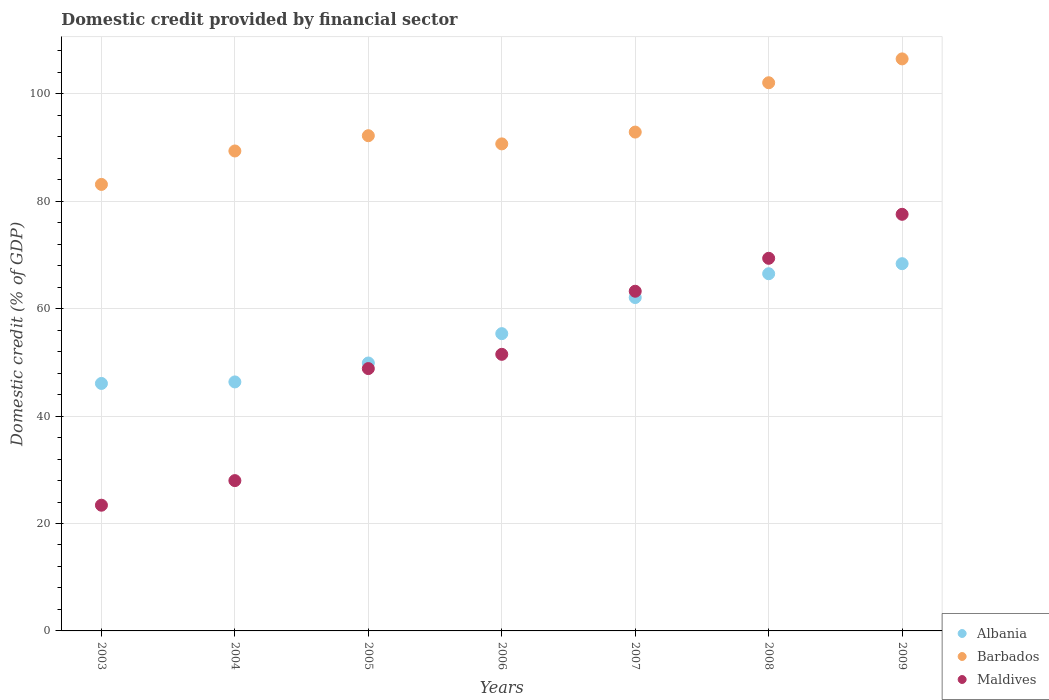How many different coloured dotlines are there?
Keep it short and to the point. 3. What is the domestic credit in Barbados in 2007?
Provide a succinct answer. 92.89. Across all years, what is the maximum domestic credit in Maldives?
Offer a terse response. 77.58. Across all years, what is the minimum domestic credit in Barbados?
Give a very brief answer. 83.14. In which year was the domestic credit in Albania maximum?
Your response must be concise. 2009. What is the total domestic credit in Maldives in the graph?
Your answer should be very brief. 361.96. What is the difference between the domestic credit in Maldives in 2004 and that in 2008?
Your response must be concise. -41.39. What is the difference between the domestic credit in Barbados in 2008 and the domestic credit in Albania in 2007?
Your response must be concise. 40. What is the average domestic credit in Maldives per year?
Provide a succinct answer. 51.71. In the year 2004, what is the difference between the domestic credit in Barbados and domestic credit in Albania?
Your answer should be very brief. 43. What is the ratio of the domestic credit in Maldives in 2005 to that in 2008?
Your response must be concise. 0.7. Is the difference between the domestic credit in Barbados in 2004 and 2006 greater than the difference between the domestic credit in Albania in 2004 and 2006?
Your answer should be compact. Yes. What is the difference between the highest and the second highest domestic credit in Barbados?
Your answer should be compact. 4.44. What is the difference between the highest and the lowest domestic credit in Albania?
Ensure brevity in your answer.  22.3. Is it the case that in every year, the sum of the domestic credit in Barbados and domestic credit in Albania  is greater than the domestic credit in Maldives?
Your answer should be very brief. Yes. Does the domestic credit in Maldives monotonically increase over the years?
Offer a terse response. Yes. Does the graph contain any zero values?
Provide a short and direct response. No. Does the graph contain grids?
Offer a very short reply. Yes. What is the title of the graph?
Offer a very short reply. Domestic credit provided by financial sector. What is the label or title of the Y-axis?
Offer a very short reply. Domestic credit (% of GDP). What is the Domestic credit (% of GDP) in Albania in 2003?
Offer a terse response. 46.08. What is the Domestic credit (% of GDP) of Barbados in 2003?
Offer a very short reply. 83.14. What is the Domestic credit (% of GDP) of Maldives in 2003?
Ensure brevity in your answer.  23.41. What is the Domestic credit (% of GDP) of Albania in 2004?
Your answer should be compact. 46.36. What is the Domestic credit (% of GDP) in Barbados in 2004?
Your answer should be compact. 89.37. What is the Domestic credit (% of GDP) of Maldives in 2004?
Keep it short and to the point. 27.99. What is the Domestic credit (% of GDP) in Albania in 2005?
Keep it short and to the point. 49.89. What is the Domestic credit (% of GDP) in Barbados in 2005?
Offer a very short reply. 92.21. What is the Domestic credit (% of GDP) in Maldives in 2005?
Your response must be concise. 48.85. What is the Domestic credit (% of GDP) of Albania in 2006?
Offer a terse response. 55.35. What is the Domestic credit (% of GDP) in Barbados in 2006?
Your response must be concise. 90.69. What is the Domestic credit (% of GDP) in Maldives in 2006?
Offer a very short reply. 51.5. What is the Domestic credit (% of GDP) of Albania in 2007?
Offer a terse response. 62.08. What is the Domestic credit (% of GDP) of Barbados in 2007?
Your answer should be compact. 92.89. What is the Domestic credit (% of GDP) of Maldives in 2007?
Give a very brief answer. 63.25. What is the Domestic credit (% of GDP) of Albania in 2008?
Ensure brevity in your answer.  66.51. What is the Domestic credit (% of GDP) of Barbados in 2008?
Your answer should be compact. 102.07. What is the Domestic credit (% of GDP) in Maldives in 2008?
Your answer should be very brief. 69.38. What is the Domestic credit (% of GDP) of Albania in 2009?
Give a very brief answer. 68.38. What is the Domestic credit (% of GDP) of Barbados in 2009?
Ensure brevity in your answer.  106.52. What is the Domestic credit (% of GDP) in Maldives in 2009?
Make the answer very short. 77.58. Across all years, what is the maximum Domestic credit (% of GDP) of Albania?
Provide a short and direct response. 68.38. Across all years, what is the maximum Domestic credit (% of GDP) of Barbados?
Your answer should be compact. 106.52. Across all years, what is the maximum Domestic credit (% of GDP) of Maldives?
Give a very brief answer. 77.58. Across all years, what is the minimum Domestic credit (% of GDP) of Albania?
Your answer should be very brief. 46.08. Across all years, what is the minimum Domestic credit (% of GDP) of Barbados?
Offer a very short reply. 83.14. Across all years, what is the minimum Domestic credit (% of GDP) of Maldives?
Provide a succinct answer. 23.41. What is the total Domestic credit (% of GDP) of Albania in the graph?
Give a very brief answer. 394.66. What is the total Domestic credit (% of GDP) of Barbados in the graph?
Give a very brief answer. 656.89. What is the total Domestic credit (% of GDP) of Maldives in the graph?
Offer a very short reply. 361.96. What is the difference between the Domestic credit (% of GDP) of Albania in 2003 and that in 2004?
Your answer should be compact. -0.28. What is the difference between the Domestic credit (% of GDP) in Barbados in 2003 and that in 2004?
Offer a terse response. -6.23. What is the difference between the Domestic credit (% of GDP) of Maldives in 2003 and that in 2004?
Provide a succinct answer. -4.58. What is the difference between the Domestic credit (% of GDP) of Albania in 2003 and that in 2005?
Your answer should be compact. -3.81. What is the difference between the Domestic credit (% of GDP) in Barbados in 2003 and that in 2005?
Offer a terse response. -9.07. What is the difference between the Domestic credit (% of GDP) in Maldives in 2003 and that in 2005?
Make the answer very short. -25.44. What is the difference between the Domestic credit (% of GDP) of Albania in 2003 and that in 2006?
Keep it short and to the point. -9.27. What is the difference between the Domestic credit (% of GDP) of Barbados in 2003 and that in 2006?
Keep it short and to the point. -7.55. What is the difference between the Domestic credit (% of GDP) of Maldives in 2003 and that in 2006?
Make the answer very short. -28.1. What is the difference between the Domestic credit (% of GDP) in Albania in 2003 and that in 2007?
Your answer should be very brief. -16. What is the difference between the Domestic credit (% of GDP) of Barbados in 2003 and that in 2007?
Ensure brevity in your answer.  -9.75. What is the difference between the Domestic credit (% of GDP) in Maldives in 2003 and that in 2007?
Give a very brief answer. -39.84. What is the difference between the Domestic credit (% of GDP) in Albania in 2003 and that in 2008?
Your answer should be very brief. -20.43. What is the difference between the Domestic credit (% of GDP) of Barbados in 2003 and that in 2008?
Your answer should be compact. -18.93. What is the difference between the Domestic credit (% of GDP) of Maldives in 2003 and that in 2008?
Keep it short and to the point. -45.98. What is the difference between the Domestic credit (% of GDP) of Albania in 2003 and that in 2009?
Provide a succinct answer. -22.3. What is the difference between the Domestic credit (% of GDP) in Barbados in 2003 and that in 2009?
Ensure brevity in your answer.  -23.37. What is the difference between the Domestic credit (% of GDP) of Maldives in 2003 and that in 2009?
Give a very brief answer. -54.17. What is the difference between the Domestic credit (% of GDP) of Albania in 2004 and that in 2005?
Provide a succinct answer. -3.52. What is the difference between the Domestic credit (% of GDP) of Barbados in 2004 and that in 2005?
Provide a short and direct response. -2.84. What is the difference between the Domestic credit (% of GDP) of Maldives in 2004 and that in 2005?
Your response must be concise. -20.86. What is the difference between the Domestic credit (% of GDP) of Albania in 2004 and that in 2006?
Make the answer very short. -8.99. What is the difference between the Domestic credit (% of GDP) of Barbados in 2004 and that in 2006?
Make the answer very short. -1.32. What is the difference between the Domestic credit (% of GDP) in Maldives in 2004 and that in 2006?
Your response must be concise. -23.52. What is the difference between the Domestic credit (% of GDP) of Albania in 2004 and that in 2007?
Make the answer very short. -15.71. What is the difference between the Domestic credit (% of GDP) of Barbados in 2004 and that in 2007?
Offer a very short reply. -3.52. What is the difference between the Domestic credit (% of GDP) of Maldives in 2004 and that in 2007?
Your answer should be compact. -35.26. What is the difference between the Domestic credit (% of GDP) of Albania in 2004 and that in 2008?
Offer a terse response. -20.15. What is the difference between the Domestic credit (% of GDP) of Barbados in 2004 and that in 2008?
Provide a short and direct response. -12.7. What is the difference between the Domestic credit (% of GDP) of Maldives in 2004 and that in 2008?
Your answer should be very brief. -41.4. What is the difference between the Domestic credit (% of GDP) of Albania in 2004 and that in 2009?
Ensure brevity in your answer.  -22.02. What is the difference between the Domestic credit (% of GDP) of Barbados in 2004 and that in 2009?
Your response must be concise. -17.15. What is the difference between the Domestic credit (% of GDP) of Maldives in 2004 and that in 2009?
Your answer should be very brief. -49.59. What is the difference between the Domestic credit (% of GDP) of Albania in 2005 and that in 2006?
Keep it short and to the point. -5.47. What is the difference between the Domestic credit (% of GDP) in Barbados in 2005 and that in 2006?
Ensure brevity in your answer.  1.52. What is the difference between the Domestic credit (% of GDP) in Maldives in 2005 and that in 2006?
Your answer should be very brief. -2.66. What is the difference between the Domestic credit (% of GDP) of Albania in 2005 and that in 2007?
Offer a very short reply. -12.19. What is the difference between the Domestic credit (% of GDP) of Barbados in 2005 and that in 2007?
Your answer should be very brief. -0.68. What is the difference between the Domestic credit (% of GDP) in Maldives in 2005 and that in 2007?
Provide a succinct answer. -14.4. What is the difference between the Domestic credit (% of GDP) of Albania in 2005 and that in 2008?
Your response must be concise. -16.62. What is the difference between the Domestic credit (% of GDP) in Barbados in 2005 and that in 2008?
Provide a succinct answer. -9.86. What is the difference between the Domestic credit (% of GDP) in Maldives in 2005 and that in 2008?
Ensure brevity in your answer.  -20.54. What is the difference between the Domestic credit (% of GDP) in Albania in 2005 and that in 2009?
Ensure brevity in your answer.  -18.49. What is the difference between the Domestic credit (% of GDP) in Barbados in 2005 and that in 2009?
Your answer should be very brief. -14.3. What is the difference between the Domestic credit (% of GDP) in Maldives in 2005 and that in 2009?
Ensure brevity in your answer.  -28.73. What is the difference between the Domestic credit (% of GDP) in Albania in 2006 and that in 2007?
Give a very brief answer. -6.72. What is the difference between the Domestic credit (% of GDP) in Barbados in 2006 and that in 2007?
Offer a terse response. -2.2. What is the difference between the Domestic credit (% of GDP) of Maldives in 2006 and that in 2007?
Provide a short and direct response. -11.75. What is the difference between the Domestic credit (% of GDP) of Albania in 2006 and that in 2008?
Provide a short and direct response. -11.16. What is the difference between the Domestic credit (% of GDP) in Barbados in 2006 and that in 2008?
Your answer should be very brief. -11.38. What is the difference between the Domestic credit (% of GDP) of Maldives in 2006 and that in 2008?
Your response must be concise. -17.88. What is the difference between the Domestic credit (% of GDP) in Albania in 2006 and that in 2009?
Offer a terse response. -13.03. What is the difference between the Domestic credit (% of GDP) in Barbados in 2006 and that in 2009?
Make the answer very short. -15.83. What is the difference between the Domestic credit (% of GDP) of Maldives in 2006 and that in 2009?
Your response must be concise. -26.07. What is the difference between the Domestic credit (% of GDP) in Albania in 2007 and that in 2008?
Provide a succinct answer. -4.44. What is the difference between the Domestic credit (% of GDP) of Barbados in 2007 and that in 2008?
Keep it short and to the point. -9.19. What is the difference between the Domestic credit (% of GDP) in Maldives in 2007 and that in 2008?
Offer a terse response. -6.13. What is the difference between the Domestic credit (% of GDP) of Albania in 2007 and that in 2009?
Keep it short and to the point. -6.31. What is the difference between the Domestic credit (% of GDP) in Barbados in 2007 and that in 2009?
Provide a short and direct response. -13.63. What is the difference between the Domestic credit (% of GDP) in Maldives in 2007 and that in 2009?
Your answer should be compact. -14.33. What is the difference between the Domestic credit (% of GDP) in Albania in 2008 and that in 2009?
Offer a terse response. -1.87. What is the difference between the Domestic credit (% of GDP) in Barbados in 2008 and that in 2009?
Offer a very short reply. -4.44. What is the difference between the Domestic credit (% of GDP) in Maldives in 2008 and that in 2009?
Offer a very short reply. -8.19. What is the difference between the Domestic credit (% of GDP) of Albania in 2003 and the Domestic credit (% of GDP) of Barbados in 2004?
Provide a short and direct response. -43.29. What is the difference between the Domestic credit (% of GDP) in Albania in 2003 and the Domestic credit (% of GDP) in Maldives in 2004?
Give a very brief answer. 18.09. What is the difference between the Domestic credit (% of GDP) of Barbados in 2003 and the Domestic credit (% of GDP) of Maldives in 2004?
Your answer should be very brief. 55.15. What is the difference between the Domestic credit (% of GDP) of Albania in 2003 and the Domestic credit (% of GDP) of Barbados in 2005?
Provide a succinct answer. -46.13. What is the difference between the Domestic credit (% of GDP) of Albania in 2003 and the Domestic credit (% of GDP) of Maldives in 2005?
Your response must be concise. -2.77. What is the difference between the Domestic credit (% of GDP) in Barbados in 2003 and the Domestic credit (% of GDP) in Maldives in 2005?
Your response must be concise. 34.29. What is the difference between the Domestic credit (% of GDP) in Albania in 2003 and the Domestic credit (% of GDP) in Barbados in 2006?
Give a very brief answer. -44.61. What is the difference between the Domestic credit (% of GDP) in Albania in 2003 and the Domestic credit (% of GDP) in Maldives in 2006?
Offer a very short reply. -5.42. What is the difference between the Domestic credit (% of GDP) of Barbados in 2003 and the Domestic credit (% of GDP) of Maldives in 2006?
Your answer should be very brief. 31.64. What is the difference between the Domestic credit (% of GDP) in Albania in 2003 and the Domestic credit (% of GDP) in Barbados in 2007?
Your response must be concise. -46.81. What is the difference between the Domestic credit (% of GDP) of Albania in 2003 and the Domestic credit (% of GDP) of Maldives in 2007?
Ensure brevity in your answer.  -17.17. What is the difference between the Domestic credit (% of GDP) of Barbados in 2003 and the Domestic credit (% of GDP) of Maldives in 2007?
Ensure brevity in your answer.  19.89. What is the difference between the Domestic credit (% of GDP) in Albania in 2003 and the Domestic credit (% of GDP) in Barbados in 2008?
Give a very brief answer. -55.99. What is the difference between the Domestic credit (% of GDP) of Albania in 2003 and the Domestic credit (% of GDP) of Maldives in 2008?
Provide a succinct answer. -23.3. What is the difference between the Domestic credit (% of GDP) of Barbados in 2003 and the Domestic credit (% of GDP) of Maldives in 2008?
Your response must be concise. 13.76. What is the difference between the Domestic credit (% of GDP) of Albania in 2003 and the Domestic credit (% of GDP) of Barbados in 2009?
Provide a succinct answer. -60.44. What is the difference between the Domestic credit (% of GDP) in Albania in 2003 and the Domestic credit (% of GDP) in Maldives in 2009?
Your response must be concise. -31.5. What is the difference between the Domestic credit (% of GDP) of Barbados in 2003 and the Domestic credit (% of GDP) of Maldives in 2009?
Keep it short and to the point. 5.57. What is the difference between the Domestic credit (% of GDP) of Albania in 2004 and the Domestic credit (% of GDP) of Barbados in 2005?
Make the answer very short. -45.85. What is the difference between the Domestic credit (% of GDP) of Albania in 2004 and the Domestic credit (% of GDP) of Maldives in 2005?
Offer a terse response. -2.48. What is the difference between the Domestic credit (% of GDP) in Barbados in 2004 and the Domestic credit (% of GDP) in Maldives in 2005?
Your answer should be very brief. 40.52. What is the difference between the Domestic credit (% of GDP) of Albania in 2004 and the Domestic credit (% of GDP) of Barbados in 2006?
Ensure brevity in your answer.  -44.33. What is the difference between the Domestic credit (% of GDP) in Albania in 2004 and the Domestic credit (% of GDP) in Maldives in 2006?
Offer a very short reply. -5.14. What is the difference between the Domestic credit (% of GDP) in Barbados in 2004 and the Domestic credit (% of GDP) in Maldives in 2006?
Keep it short and to the point. 37.86. What is the difference between the Domestic credit (% of GDP) of Albania in 2004 and the Domestic credit (% of GDP) of Barbados in 2007?
Ensure brevity in your answer.  -46.52. What is the difference between the Domestic credit (% of GDP) of Albania in 2004 and the Domestic credit (% of GDP) of Maldives in 2007?
Give a very brief answer. -16.89. What is the difference between the Domestic credit (% of GDP) of Barbados in 2004 and the Domestic credit (% of GDP) of Maldives in 2007?
Your response must be concise. 26.12. What is the difference between the Domestic credit (% of GDP) of Albania in 2004 and the Domestic credit (% of GDP) of Barbados in 2008?
Your answer should be compact. -55.71. What is the difference between the Domestic credit (% of GDP) of Albania in 2004 and the Domestic credit (% of GDP) of Maldives in 2008?
Your answer should be very brief. -23.02. What is the difference between the Domestic credit (% of GDP) in Barbados in 2004 and the Domestic credit (% of GDP) in Maldives in 2008?
Keep it short and to the point. 19.99. What is the difference between the Domestic credit (% of GDP) of Albania in 2004 and the Domestic credit (% of GDP) of Barbados in 2009?
Your answer should be very brief. -60.15. What is the difference between the Domestic credit (% of GDP) of Albania in 2004 and the Domestic credit (% of GDP) of Maldives in 2009?
Your response must be concise. -31.21. What is the difference between the Domestic credit (% of GDP) of Barbados in 2004 and the Domestic credit (% of GDP) of Maldives in 2009?
Your response must be concise. 11.79. What is the difference between the Domestic credit (% of GDP) in Albania in 2005 and the Domestic credit (% of GDP) in Barbados in 2006?
Offer a very short reply. -40.8. What is the difference between the Domestic credit (% of GDP) in Albania in 2005 and the Domestic credit (% of GDP) in Maldives in 2006?
Provide a short and direct response. -1.62. What is the difference between the Domestic credit (% of GDP) of Barbados in 2005 and the Domestic credit (% of GDP) of Maldives in 2006?
Offer a very short reply. 40.71. What is the difference between the Domestic credit (% of GDP) in Albania in 2005 and the Domestic credit (% of GDP) in Barbados in 2007?
Your answer should be very brief. -43. What is the difference between the Domestic credit (% of GDP) in Albania in 2005 and the Domestic credit (% of GDP) in Maldives in 2007?
Offer a very short reply. -13.36. What is the difference between the Domestic credit (% of GDP) of Barbados in 2005 and the Domestic credit (% of GDP) of Maldives in 2007?
Offer a very short reply. 28.96. What is the difference between the Domestic credit (% of GDP) in Albania in 2005 and the Domestic credit (% of GDP) in Barbados in 2008?
Your answer should be very brief. -52.19. What is the difference between the Domestic credit (% of GDP) in Albania in 2005 and the Domestic credit (% of GDP) in Maldives in 2008?
Make the answer very short. -19.5. What is the difference between the Domestic credit (% of GDP) in Barbados in 2005 and the Domestic credit (% of GDP) in Maldives in 2008?
Keep it short and to the point. 22.83. What is the difference between the Domestic credit (% of GDP) of Albania in 2005 and the Domestic credit (% of GDP) of Barbados in 2009?
Give a very brief answer. -56.63. What is the difference between the Domestic credit (% of GDP) in Albania in 2005 and the Domestic credit (% of GDP) in Maldives in 2009?
Offer a very short reply. -27.69. What is the difference between the Domestic credit (% of GDP) in Barbados in 2005 and the Domestic credit (% of GDP) in Maldives in 2009?
Provide a short and direct response. 14.64. What is the difference between the Domestic credit (% of GDP) of Albania in 2006 and the Domestic credit (% of GDP) of Barbados in 2007?
Your response must be concise. -37.53. What is the difference between the Domestic credit (% of GDP) of Albania in 2006 and the Domestic credit (% of GDP) of Maldives in 2007?
Your response must be concise. -7.9. What is the difference between the Domestic credit (% of GDP) in Barbados in 2006 and the Domestic credit (% of GDP) in Maldives in 2007?
Make the answer very short. 27.44. What is the difference between the Domestic credit (% of GDP) in Albania in 2006 and the Domestic credit (% of GDP) in Barbados in 2008?
Make the answer very short. -46.72. What is the difference between the Domestic credit (% of GDP) of Albania in 2006 and the Domestic credit (% of GDP) of Maldives in 2008?
Ensure brevity in your answer.  -14.03. What is the difference between the Domestic credit (% of GDP) of Barbados in 2006 and the Domestic credit (% of GDP) of Maldives in 2008?
Provide a succinct answer. 21.31. What is the difference between the Domestic credit (% of GDP) in Albania in 2006 and the Domestic credit (% of GDP) in Barbados in 2009?
Your answer should be very brief. -51.16. What is the difference between the Domestic credit (% of GDP) in Albania in 2006 and the Domestic credit (% of GDP) in Maldives in 2009?
Your response must be concise. -22.22. What is the difference between the Domestic credit (% of GDP) in Barbados in 2006 and the Domestic credit (% of GDP) in Maldives in 2009?
Provide a short and direct response. 13.11. What is the difference between the Domestic credit (% of GDP) of Albania in 2007 and the Domestic credit (% of GDP) of Barbados in 2008?
Offer a very short reply. -40. What is the difference between the Domestic credit (% of GDP) of Albania in 2007 and the Domestic credit (% of GDP) of Maldives in 2008?
Offer a very short reply. -7.31. What is the difference between the Domestic credit (% of GDP) of Barbados in 2007 and the Domestic credit (% of GDP) of Maldives in 2008?
Provide a short and direct response. 23.5. What is the difference between the Domestic credit (% of GDP) of Albania in 2007 and the Domestic credit (% of GDP) of Barbados in 2009?
Provide a succinct answer. -44.44. What is the difference between the Domestic credit (% of GDP) in Albania in 2007 and the Domestic credit (% of GDP) in Maldives in 2009?
Offer a very short reply. -15.5. What is the difference between the Domestic credit (% of GDP) of Barbados in 2007 and the Domestic credit (% of GDP) of Maldives in 2009?
Provide a short and direct response. 15.31. What is the difference between the Domestic credit (% of GDP) in Albania in 2008 and the Domestic credit (% of GDP) in Barbados in 2009?
Provide a succinct answer. -40. What is the difference between the Domestic credit (% of GDP) of Albania in 2008 and the Domestic credit (% of GDP) of Maldives in 2009?
Your response must be concise. -11.06. What is the difference between the Domestic credit (% of GDP) in Barbados in 2008 and the Domestic credit (% of GDP) in Maldives in 2009?
Your answer should be compact. 24.5. What is the average Domestic credit (% of GDP) in Albania per year?
Make the answer very short. 56.38. What is the average Domestic credit (% of GDP) in Barbados per year?
Make the answer very short. 93.84. What is the average Domestic credit (% of GDP) in Maldives per year?
Your response must be concise. 51.71. In the year 2003, what is the difference between the Domestic credit (% of GDP) of Albania and Domestic credit (% of GDP) of Barbados?
Offer a very short reply. -37.06. In the year 2003, what is the difference between the Domestic credit (% of GDP) of Albania and Domestic credit (% of GDP) of Maldives?
Your answer should be very brief. 22.67. In the year 2003, what is the difference between the Domestic credit (% of GDP) of Barbados and Domestic credit (% of GDP) of Maldives?
Make the answer very short. 59.73. In the year 2004, what is the difference between the Domestic credit (% of GDP) in Albania and Domestic credit (% of GDP) in Barbados?
Make the answer very short. -43.01. In the year 2004, what is the difference between the Domestic credit (% of GDP) of Albania and Domestic credit (% of GDP) of Maldives?
Ensure brevity in your answer.  18.38. In the year 2004, what is the difference between the Domestic credit (% of GDP) of Barbados and Domestic credit (% of GDP) of Maldives?
Ensure brevity in your answer.  61.38. In the year 2005, what is the difference between the Domestic credit (% of GDP) in Albania and Domestic credit (% of GDP) in Barbados?
Your answer should be very brief. -42.32. In the year 2005, what is the difference between the Domestic credit (% of GDP) in Albania and Domestic credit (% of GDP) in Maldives?
Offer a terse response. 1.04. In the year 2005, what is the difference between the Domestic credit (% of GDP) in Barbados and Domestic credit (% of GDP) in Maldives?
Offer a terse response. 43.36. In the year 2006, what is the difference between the Domestic credit (% of GDP) in Albania and Domestic credit (% of GDP) in Barbados?
Give a very brief answer. -35.33. In the year 2006, what is the difference between the Domestic credit (% of GDP) of Albania and Domestic credit (% of GDP) of Maldives?
Keep it short and to the point. 3.85. In the year 2006, what is the difference between the Domestic credit (% of GDP) of Barbados and Domestic credit (% of GDP) of Maldives?
Provide a succinct answer. 39.18. In the year 2007, what is the difference between the Domestic credit (% of GDP) of Albania and Domestic credit (% of GDP) of Barbados?
Offer a very short reply. -30.81. In the year 2007, what is the difference between the Domestic credit (% of GDP) of Albania and Domestic credit (% of GDP) of Maldives?
Provide a short and direct response. -1.17. In the year 2007, what is the difference between the Domestic credit (% of GDP) of Barbados and Domestic credit (% of GDP) of Maldives?
Give a very brief answer. 29.64. In the year 2008, what is the difference between the Domestic credit (% of GDP) of Albania and Domestic credit (% of GDP) of Barbados?
Provide a short and direct response. -35.56. In the year 2008, what is the difference between the Domestic credit (% of GDP) of Albania and Domestic credit (% of GDP) of Maldives?
Keep it short and to the point. -2.87. In the year 2008, what is the difference between the Domestic credit (% of GDP) of Barbados and Domestic credit (% of GDP) of Maldives?
Offer a very short reply. 32.69. In the year 2009, what is the difference between the Domestic credit (% of GDP) of Albania and Domestic credit (% of GDP) of Barbados?
Offer a terse response. -38.13. In the year 2009, what is the difference between the Domestic credit (% of GDP) of Albania and Domestic credit (% of GDP) of Maldives?
Your response must be concise. -9.19. In the year 2009, what is the difference between the Domestic credit (% of GDP) in Barbados and Domestic credit (% of GDP) in Maldives?
Your answer should be very brief. 28.94. What is the ratio of the Domestic credit (% of GDP) of Barbados in 2003 to that in 2004?
Provide a short and direct response. 0.93. What is the ratio of the Domestic credit (% of GDP) in Maldives in 2003 to that in 2004?
Offer a very short reply. 0.84. What is the ratio of the Domestic credit (% of GDP) of Albania in 2003 to that in 2005?
Your response must be concise. 0.92. What is the ratio of the Domestic credit (% of GDP) in Barbados in 2003 to that in 2005?
Your answer should be compact. 0.9. What is the ratio of the Domestic credit (% of GDP) of Maldives in 2003 to that in 2005?
Your response must be concise. 0.48. What is the ratio of the Domestic credit (% of GDP) of Albania in 2003 to that in 2006?
Your answer should be very brief. 0.83. What is the ratio of the Domestic credit (% of GDP) of Barbados in 2003 to that in 2006?
Ensure brevity in your answer.  0.92. What is the ratio of the Domestic credit (% of GDP) in Maldives in 2003 to that in 2006?
Give a very brief answer. 0.45. What is the ratio of the Domestic credit (% of GDP) in Albania in 2003 to that in 2007?
Make the answer very short. 0.74. What is the ratio of the Domestic credit (% of GDP) in Barbados in 2003 to that in 2007?
Your answer should be compact. 0.9. What is the ratio of the Domestic credit (% of GDP) in Maldives in 2003 to that in 2007?
Your answer should be very brief. 0.37. What is the ratio of the Domestic credit (% of GDP) in Albania in 2003 to that in 2008?
Ensure brevity in your answer.  0.69. What is the ratio of the Domestic credit (% of GDP) in Barbados in 2003 to that in 2008?
Give a very brief answer. 0.81. What is the ratio of the Domestic credit (% of GDP) in Maldives in 2003 to that in 2008?
Keep it short and to the point. 0.34. What is the ratio of the Domestic credit (% of GDP) of Albania in 2003 to that in 2009?
Give a very brief answer. 0.67. What is the ratio of the Domestic credit (% of GDP) in Barbados in 2003 to that in 2009?
Offer a terse response. 0.78. What is the ratio of the Domestic credit (% of GDP) of Maldives in 2003 to that in 2009?
Make the answer very short. 0.3. What is the ratio of the Domestic credit (% of GDP) in Albania in 2004 to that in 2005?
Ensure brevity in your answer.  0.93. What is the ratio of the Domestic credit (% of GDP) in Barbados in 2004 to that in 2005?
Your answer should be compact. 0.97. What is the ratio of the Domestic credit (% of GDP) of Maldives in 2004 to that in 2005?
Offer a very short reply. 0.57. What is the ratio of the Domestic credit (% of GDP) in Albania in 2004 to that in 2006?
Provide a short and direct response. 0.84. What is the ratio of the Domestic credit (% of GDP) in Barbados in 2004 to that in 2006?
Provide a succinct answer. 0.99. What is the ratio of the Domestic credit (% of GDP) in Maldives in 2004 to that in 2006?
Your answer should be compact. 0.54. What is the ratio of the Domestic credit (% of GDP) of Albania in 2004 to that in 2007?
Your answer should be very brief. 0.75. What is the ratio of the Domestic credit (% of GDP) of Barbados in 2004 to that in 2007?
Your answer should be compact. 0.96. What is the ratio of the Domestic credit (% of GDP) in Maldives in 2004 to that in 2007?
Give a very brief answer. 0.44. What is the ratio of the Domestic credit (% of GDP) of Albania in 2004 to that in 2008?
Your answer should be very brief. 0.7. What is the ratio of the Domestic credit (% of GDP) of Barbados in 2004 to that in 2008?
Make the answer very short. 0.88. What is the ratio of the Domestic credit (% of GDP) of Maldives in 2004 to that in 2008?
Offer a terse response. 0.4. What is the ratio of the Domestic credit (% of GDP) in Albania in 2004 to that in 2009?
Offer a terse response. 0.68. What is the ratio of the Domestic credit (% of GDP) in Barbados in 2004 to that in 2009?
Your response must be concise. 0.84. What is the ratio of the Domestic credit (% of GDP) in Maldives in 2004 to that in 2009?
Your answer should be very brief. 0.36. What is the ratio of the Domestic credit (% of GDP) in Albania in 2005 to that in 2006?
Ensure brevity in your answer.  0.9. What is the ratio of the Domestic credit (% of GDP) in Barbados in 2005 to that in 2006?
Your response must be concise. 1.02. What is the ratio of the Domestic credit (% of GDP) of Maldives in 2005 to that in 2006?
Offer a very short reply. 0.95. What is the ratio of the Domestic credit (% of GDP) in Albania in 2005 to that in 2007?
Provide a short and direct response. 0.8. What is the ratio of the Domestic credit (% of GDP) of Barbados in 2005 to that in 2007?
Provide a short and direct response. 0.99. What is the ratio of the Domestic credit (% of GDP) of Maldives in 2005 to that in 2007?
Provide a short and direct response. 0.77. What is the ratio of the Domestic credit (% of GDP) in Albania in 2005 to that in 2008?
Keep it short and to the point. 0.75. What is the ratio of the Domestic credit (% of GDP) of Barbados in 2005 to that in 2008?
Your answer should be compact. 0.9. What is the ratio of the Domestic credit (% of GDP) in Maldives in 2005 to that in 2008?
Ensure brevity in your answer.  0.7. What is the ratio of the Domestic credit (% of GDP) of Albania in 2005 to that in 2009?
Offer a terse response. 0.73. What is the ratio of the Domestic credit (% of GDP) in Barbados in 2005 to that in 2009?
Make the answer very short. 0.87. What is the ratio of the Domestic credit (% of GDP) in Maldives in 2005 to that in 2009?
Offer a terse response. 0.63. What is the ratio of the Domestic credit (% of GDP) in Albania in 2006 to that in 2007?
Provide a succinct answer. 0.89. What is the ratio of the Domestic credit (% of GDP) of Barbados in 2006 to that in 2007?
Your answer should be very brief. 0.98. What is the ratio of the Domestic credit (% of GDP) of Maldives in 2006 to that in 2007?
Your response must be concise. 0.81. What is the ratio of the Domestic credit (% of GDP) in Albania in 2006 to that in 2008?
Offer a terse response. 0.83. What is the ratio of the Domestic credit (% of GDP) in Barbados in 2006 to that in 2008?
Your response must be concise. 0.89. What is the ratio of the Domestic credit (% of GDP) of Maldives in 2006 to that in 2008?
Keep it short and to the point. 0.74. What is the ratio of the Domestic credit (% of GDP) in Albania in 2006 to that in 2009?
Offer a very short reply. 0.81. What is the ratio of the Domestic credit (% of GDP) of Barbados in 2006 to that in 2009?
Your answer should be compact. 0.85. What is the ratio of the Domestic credit (% of GDP) of Maldives in 2006 to that in 2009?
Ensure brevity in your answer.  0.66. What is the ratio of the Domestic credit (% of GDP) of Barbados in 2007 to that in 2008?
Ensure brevity in your answer.  0.91. What is the ratio of the Domestic credit (% of GDP) in Maldives in 2007 to that in 2008?
Your answer should be compact. 0.91. What is the ratio of the Domestic credit (% of GDP) in Albania in 2007 to that in 2009?
Keep it short and to the point. 0.91. What is the ratio of the Domestic credit (% of GDP) of Barbados in 2007 to that in 2009?
Offer a very short reply. 0.87. What is the ratio of the Domestic credit (% of GDP) of Maldives in 2007 to that in 2009?
Ensure brevity in your answer.  0.82. What is the ratio of the Domestic credit (% of GDP) in Albania in 2008 to that in 2009?
Your answer should be very brief. 0.97. What is the ratio of the Domestic credit (% of GDP) of Maldives in 2008 to that in 2009?
Your answer should be very brief. 0.89. What is the difference between the highest and the second highest Domestic credit (% of GDP) of Albania?
Offer a very short reply. 1.87. What is the difference between the highest and the second highest Domestic credit (% of GDP) in Barbados?
Provide a short and direct response. 4.44. What is the difference between the highest and the second highest Domestic credit (% of GDP) in Maldives?
Make the answer very short. 8.19. What is the difference between the highest and the lowest Domestic credit (% of GDP) of Albania?
Offer a terse response. 22.3. What is the difference between the highest and the lowest Domestic credit (% of GDP) of Barbados?
Provide a short and direct response. 23.37. What is the difference between the highest and the lowest Domestic credit (% of GDP) of Maldives?
Offer a very short reply. 54.17. 